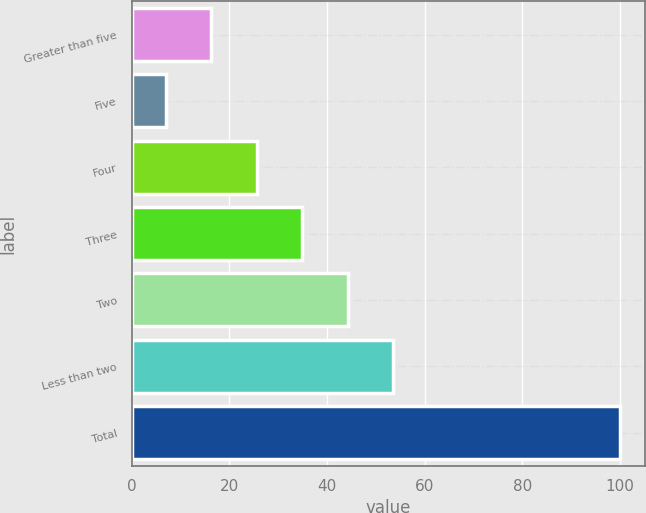Convert chart. <chart><loc_0><loc_0><loc_500><loc_500><bar_chart><fcel>Greater than five<fcel>Five<fcel>Four<fcel>Three<fcel>Two<fcel>Less than two<fcel>Total<nl><fcel>16.3<fcel>7<fcel>25.6<fcel>34.9<fcel>44.2<fcel>53.5<fcel>100<nl></chart> 